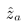Convert formula to latex. <formula><loc_0><loc_0><loc_500><loc_500>\hat { z } _ { a }</formula> 